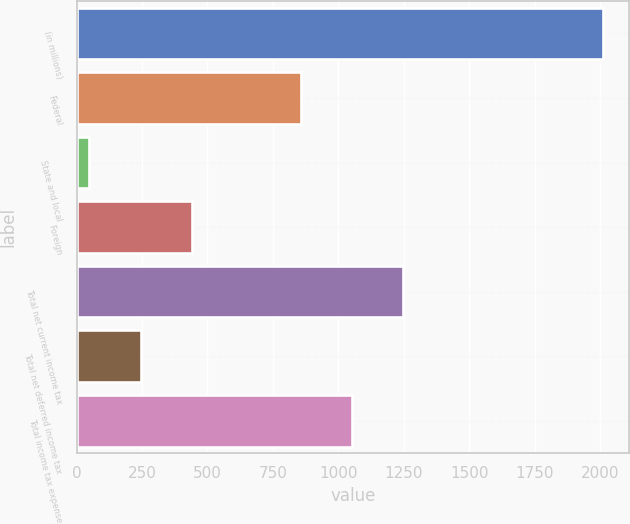Convert chart to OTSL. <chart><loc_0><loc_0><loc_500><loc_500><bar_chart><fcel>(in millions)<fcel>Federal<fcel>State and local<fcel>Foreign<fcel>Total net current income tax<fcel>Total net deferred income tax<fcel>Total income tax expense<nl><fcel>2012<fcel>856<fcel>49<fcel>441.6<fcel>1248.6<fcel>245.3<fcel>1052.3<nl></chart> 